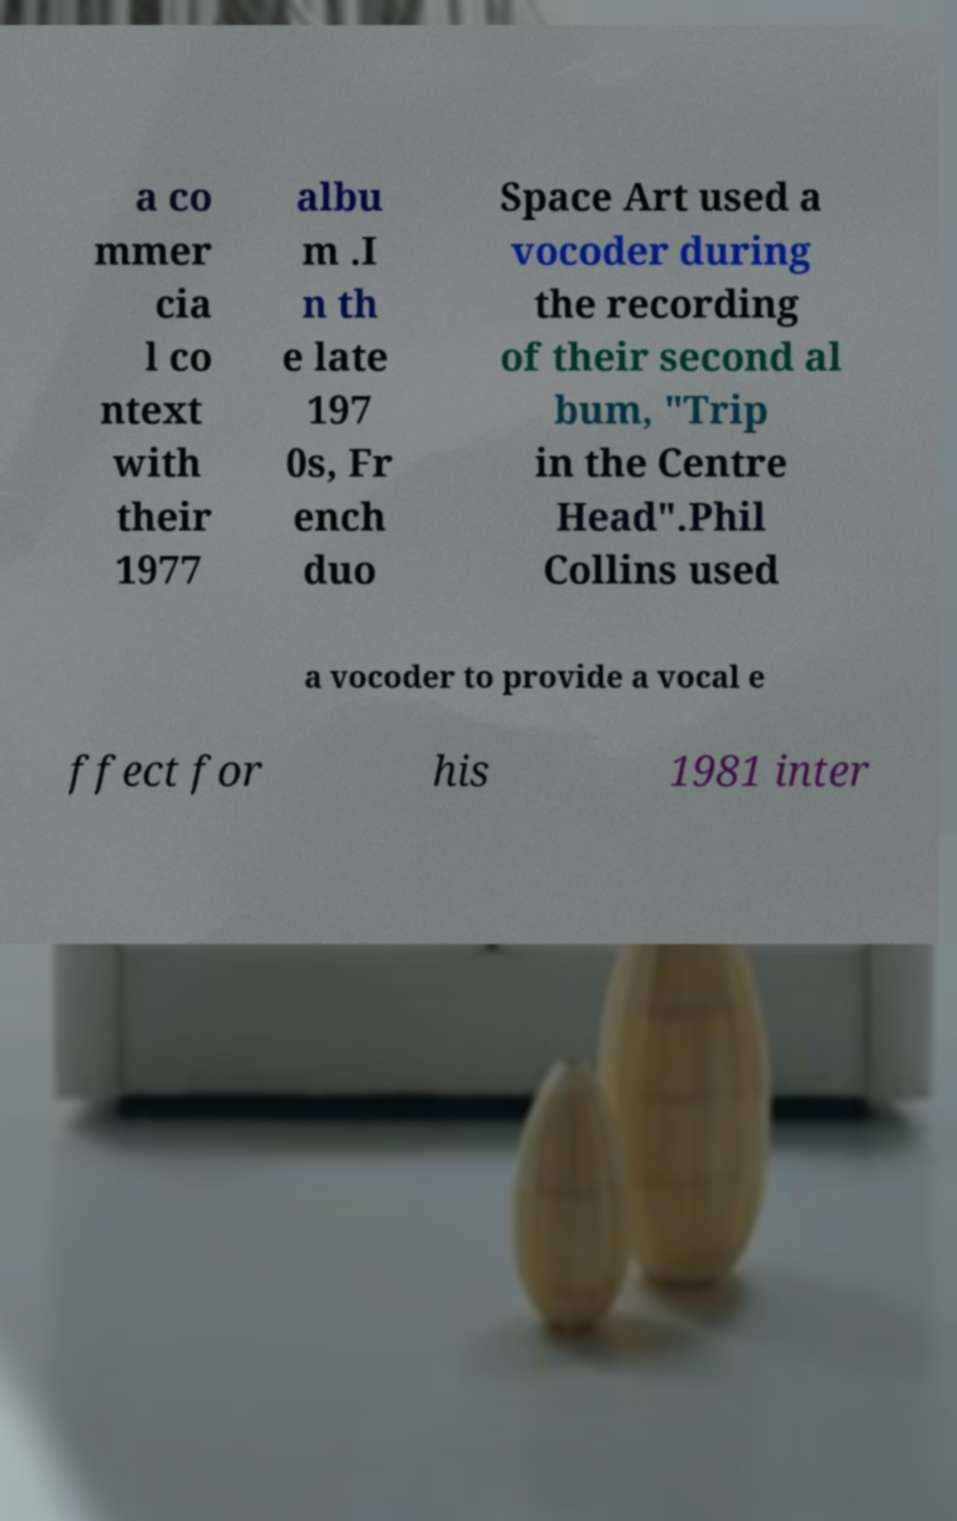Please read and relay the text visible in this image. What does it say? a co mmer cia l co ntext with their 1977 albu m .I n th e late 197 0s, Fr ench duo Space Art used a vocoder during the recording of their second al bum, "Trip in the Centre Head".Phil Collins used a vocoder to provide a vocal e ffect for his 1981 inter 